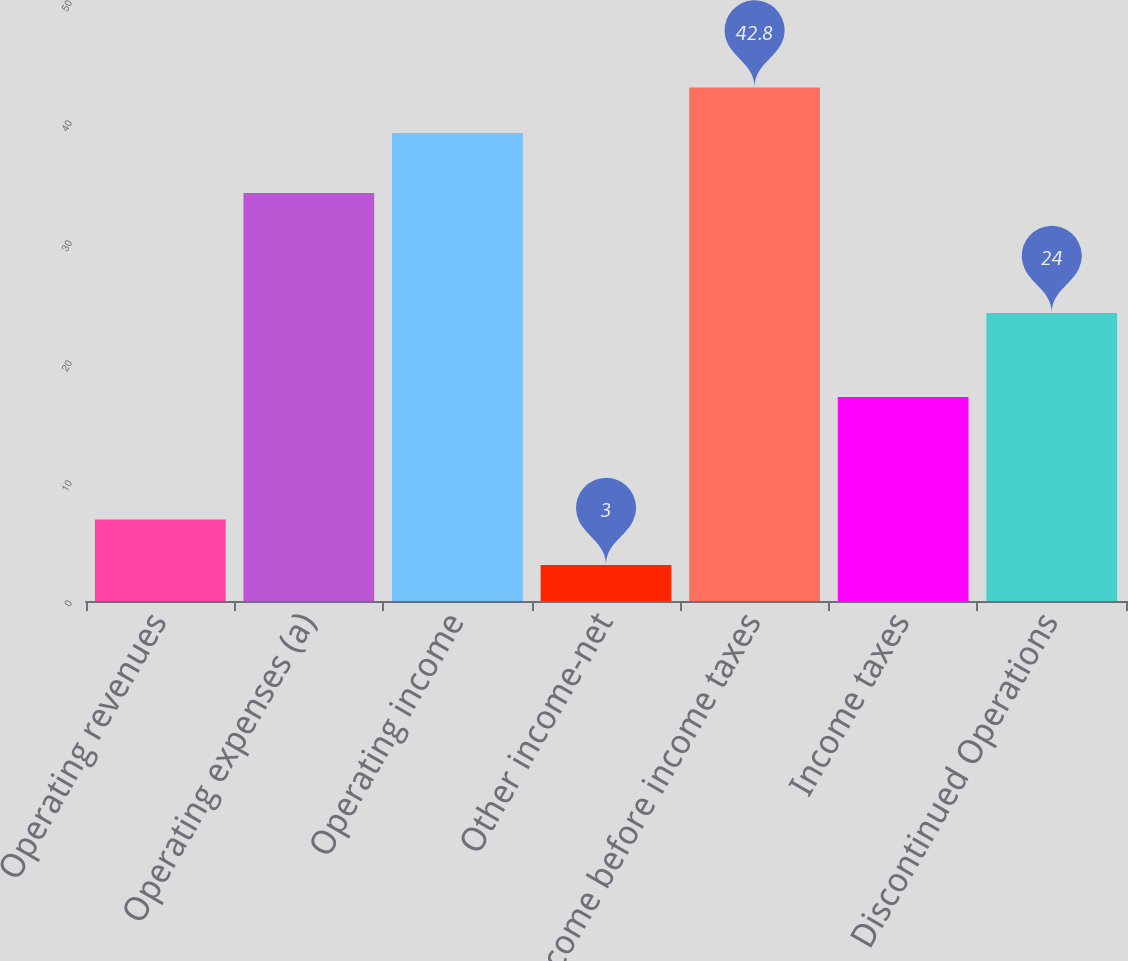Convert chart to OTSL. <chart><loc_0><loc_0><loc_500><loc_500><bar_chart><fcel>Operating revenues<fcel>Operating expenses (a)<fcel>Operating income<fcel>Other income-net<fcel>Income before income taxes<fcel>Income taxes<fcel>Discontinued Operations<nl><fcel>6.8<fcel>34<fcel>39<fcel>3<fcel>42.8<fcel>17<fcel>24<nl></chart> 